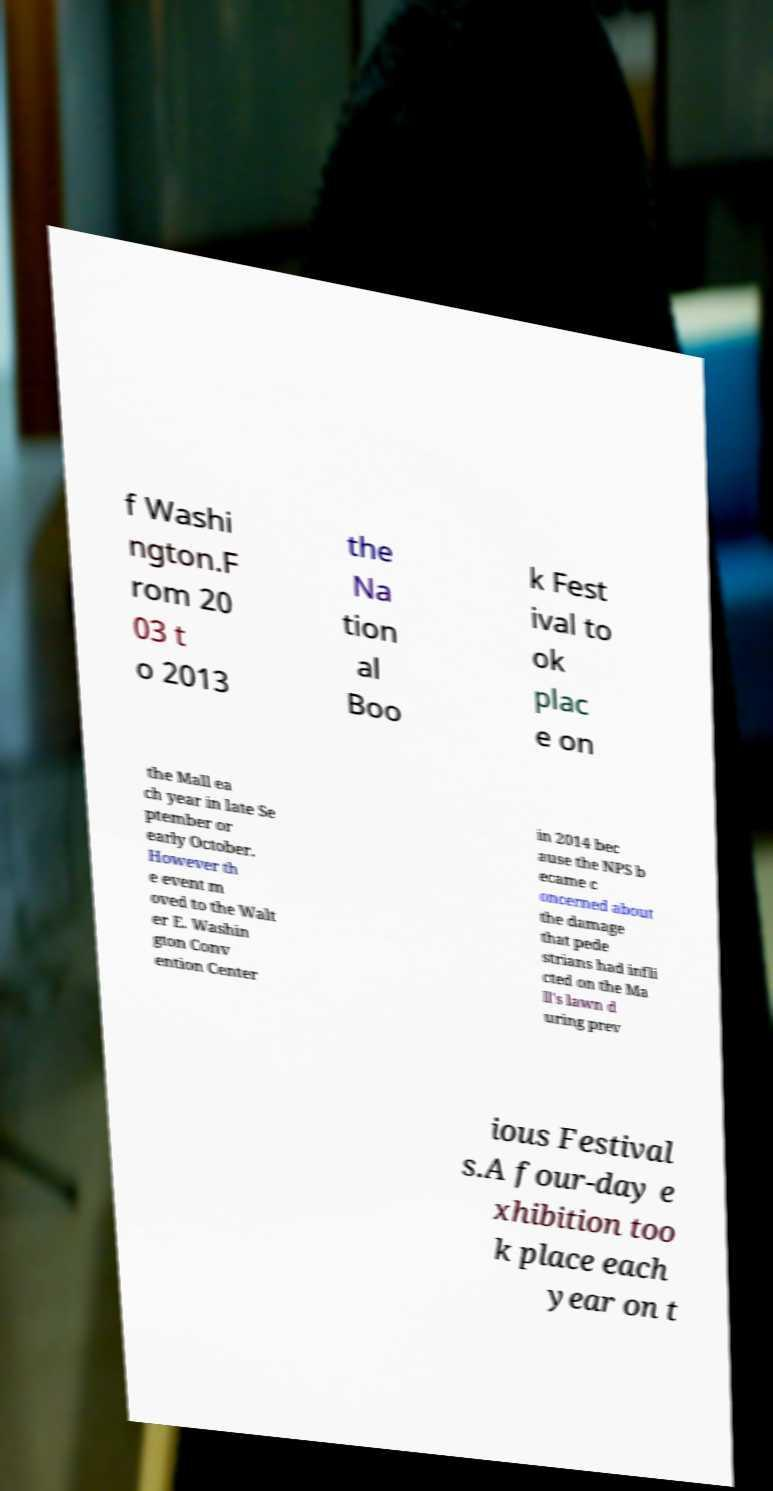Please read and relay the text visible in this image. What does it say? f Washi ngton.F rom 20 03 t o 2013 the Na tion al Boo k Fest ival to ok plac e on the Mall ea ch year in late Se ptember or early October. However th e event m oved to the Walt er E. Washin gton Conv ention Center in 2014 bec ause the NPS b ecame c oncerned about the damage that pede strians had infli cted on the Ma ll's lawn d uring prev ious Festival s.A four-day e xhibition too k place each year on t 